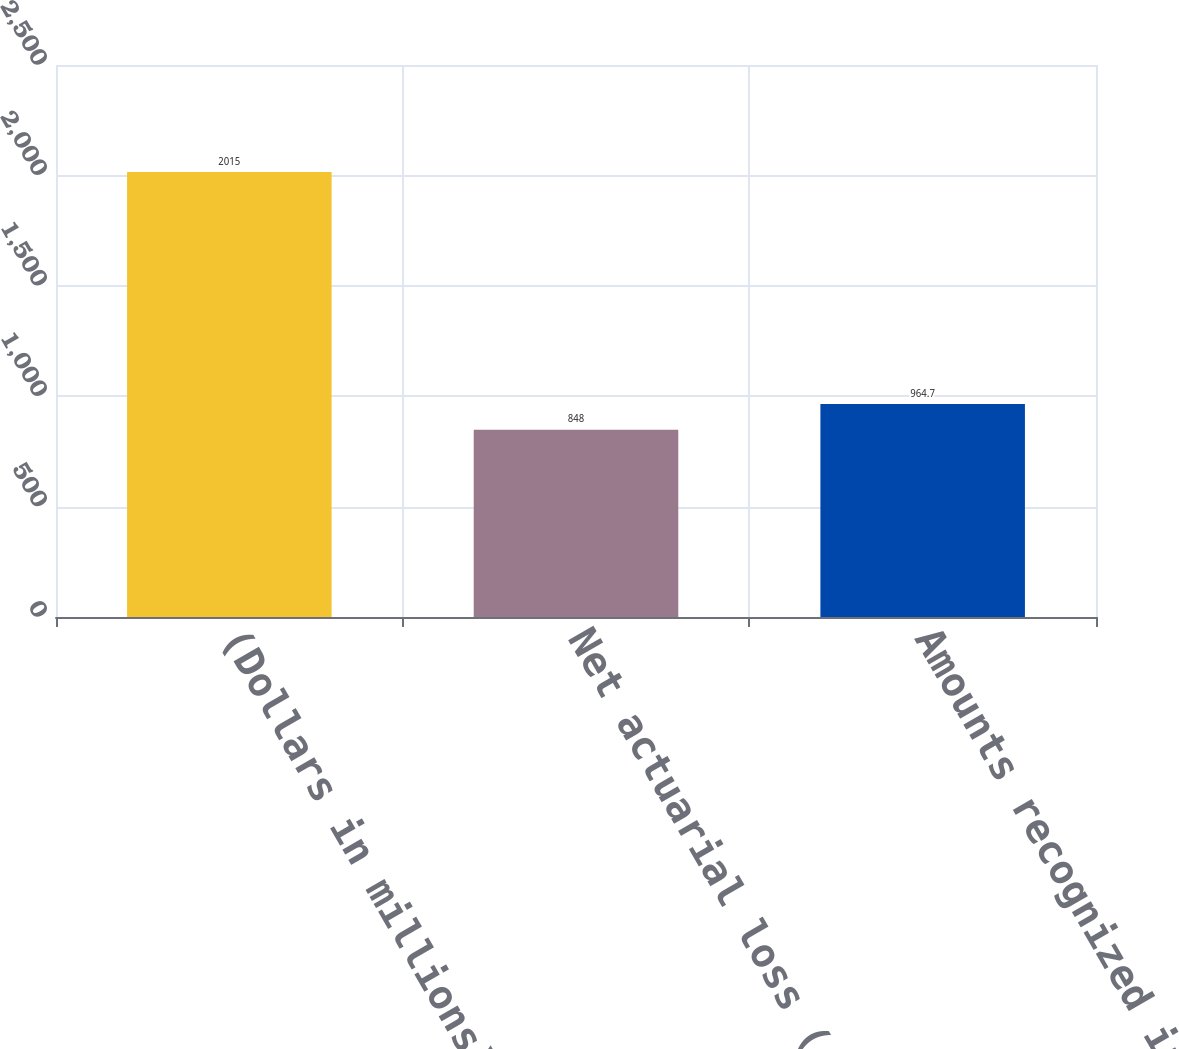Convert chart to OTSL. <chart><loc_0><loc_0><loc_500><loc_500><bar_chart><fcel>(Dollars in millions)<fcel>Net actuarial loss (gain)<fcel>Amounts recognized in<nl><fcel>2015<fcel>848<fcel>964.7<nl></chart> 